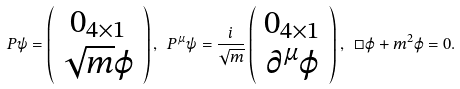Convert formula to latex. <formula><loc_0><loc_0><loc_500><loc_500>P \psi = \left ( \begin{array} { c } 0 _ { 4 \times 1 } \\ \sqrt { m } \varphi \end{array} \right ) , \ P ^ { \mu } \psi = \frac { i } { \sqrt { m } } \left ( \begin{array} { c } 0 _ { 4 \times 1 } \\ \partial ^ { \mu } \varphi \end{array} \right ) , \ \square \varphi + m ^ { 2 } \varphi = 0 .</formula> 